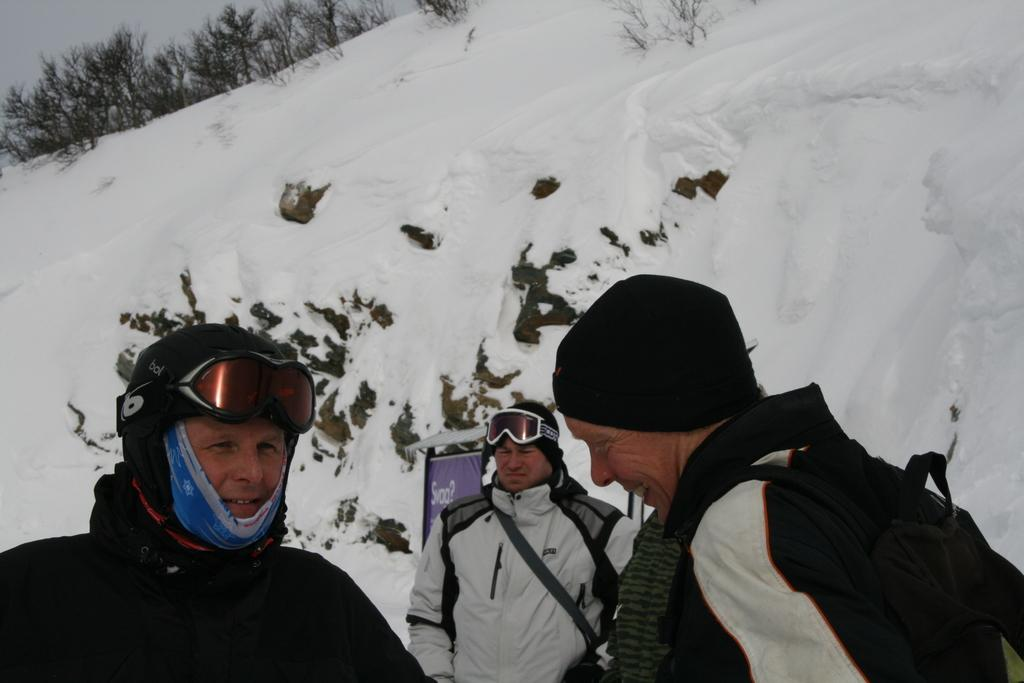How many men are in the image? There are three men in the image. What are the men wearing? The men are wearing jackets and helmets. What position are the men in? The men are standing. What can be seen in the background of the image? There is a hill covered with snow and plants visible in the background of the image. Where is the lunchroom located in the image? There is no lunchroom present in the image. What channel can be seen on the television in the image? There is no television present in the image. 